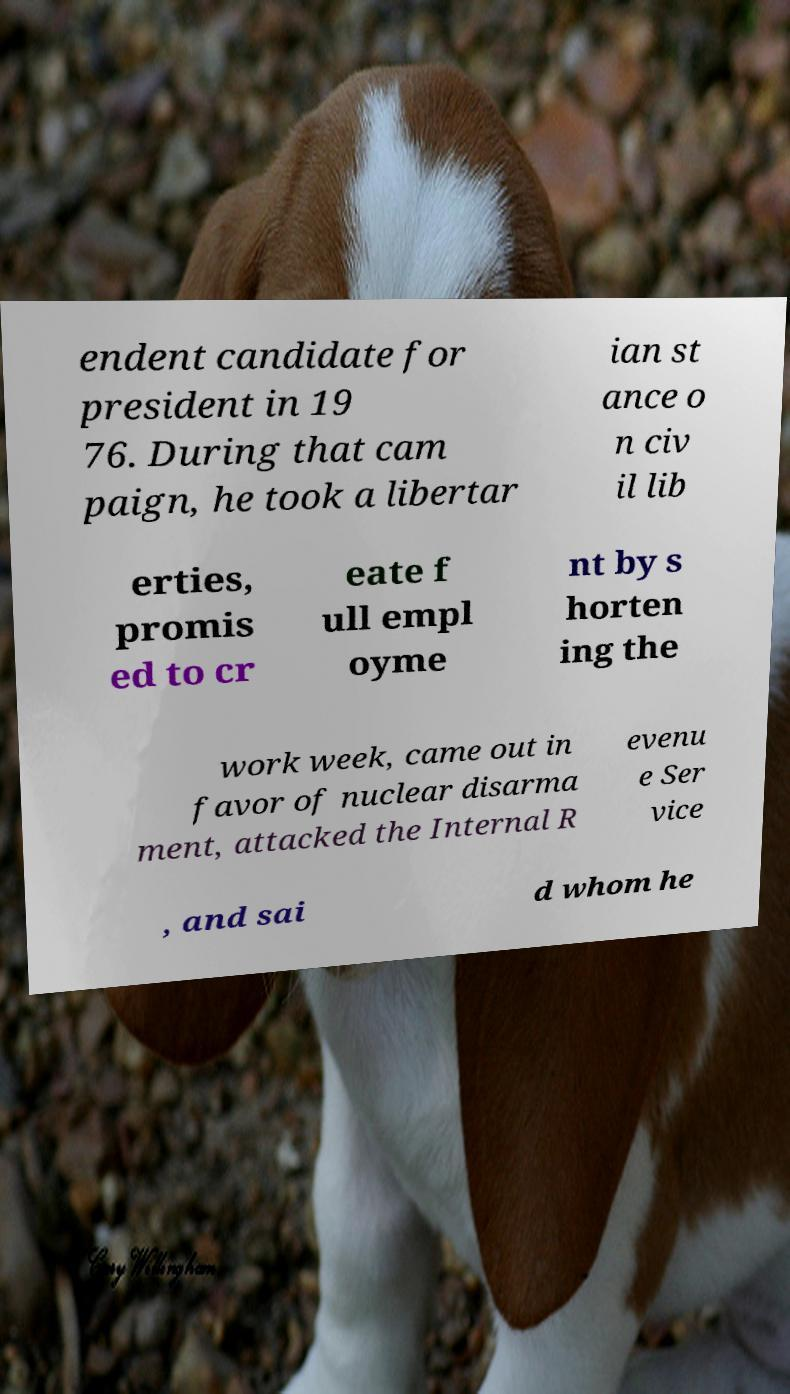Can you read and provide the text displayed in the image?This photo seems to have some interesting text. Can you extract and type it out for me? endent candidate for president in 19 76. During that cam paign, he took a libertar ian st ance o n civ il lib erties, promis ed to cr eate f ull empl oyme nt by s horten ing the work week, came out in favor of nuclear disarma ment, attacked the Internal R evenu e Ser vice , and sai d whom he 